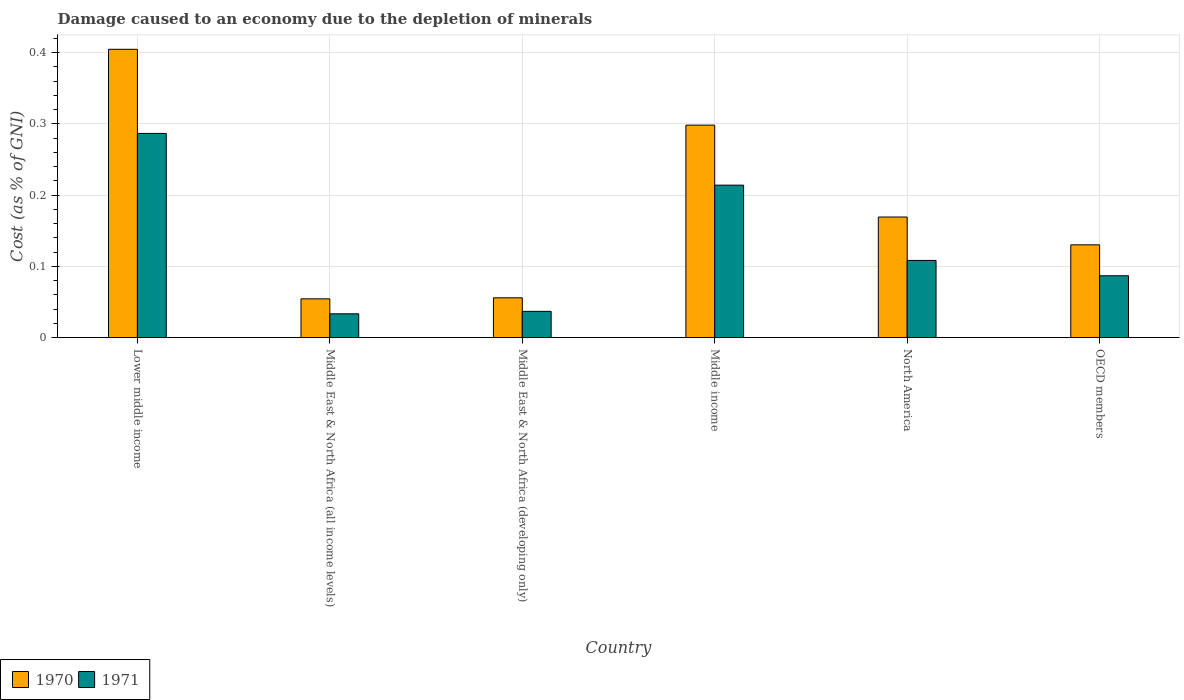How many different coloured bars are there?
Your answer should be very brief. 2. How many groups of bars are there?
Your answer should be very brief. 6. How many bars are there on the 5th tick from the left?
Provide a short and direct response. 2. How many bars are there on the 1st tick from the right?
Your response must be concise. 2. What is the cost of damage caused due to the depletion of minerals in 1970 in Lower middle income?
Ensure brevity in your answer.  0.4. Across all countries, what is the maximum cost of damage caused due to the depletion of minerals in 1970?
Your response must be concise. 0.4. Across all countries, what is the minimum cost of damage caused due to the depletion of minerals in 1970?
Your response must be concise. 0.05. In which country was the cost of damage caused due to the depletion of minerals in 1970 maximum?
Your answer should be compact. Lower middle income. In which country was the cost of damage caused due to the depletion of minerals in 1970 minimum?
Give a very brief answer. Middle East & North Africa (all income levels). What is the total cost of damage caused due to the depletion of minerals in 1970 in the graph?
Your response must be concise. 1.11. What is the difference between the cost of damage caused due to the depletion of minerals in 1971 in Middle East & North Africa (developing only) and that in OECD members?
Offer a terse response. -0.05. What is the difference between the cost of damage caused due to the depletion of minerals in 1971 in Lower middle income and the cost of damage caused due to the depletion of minerals in 1970 in Middle East & North Africa (all income levels)?
Keep it short and to the point. 0.23. What is the average cost of damage caused due to the depletion of minerals in 1971 per country?
Offer a very short reply. 0.13. What is the difference between the cost of damage caused due to the depletion of minerals of/in 1970 and cost of damage caused due to the depletion of minerals of/in 1971 in Middle East & North Africa (all income levels)?
Your answer should be very brief. 0.02. In how many countries, is the cost of damage caused due to the depletion of minerals in 1971 greater than 0.4 %?
Provide a short and direct response. 0. What is the ratio of the cost of damage caused due to the depletion of minerals in 1971 in Middle East & North Africa (all income levels) to that in Middle East & North Africa (developing only)?
Your answer should be very brief. 0.91. What is the difference between the highest and the second highest cost of damage caused due to the depletion of minerals in 1971?
Make the answer very short. 0.18. What is the difference between the highest and the lowest cost of damage caused due to the depletion of minerals in 1971?
Provide a short and direct response. 0.25. In how many countries, is the cost of damage caused due to the depletion of minerals in 1970 greater than the average cost of damage caused due to the depletion of minerals in 1970 taken over all countries?
Your response must be concise. 2. Is the sum of the cost of damage caused due to the depletion of minerals in 1970 in Middle income and OECD members greater than the maximum cost of damage caused due to the depletion of minerals in 1971 across all countries?
Keep it short and to the point. Yes. Are all the bars in the graph horizontal?
Your answer should be compact. No. Are the values on the major ticks of Y-axis written in scientific E-notation?
Your answer should be compact. No. Does the graph contain grids?
Your answer should be compact. Yes. How are the legend labels stacked?
Your answer should be very brief. Horizontal. What is the title of the graph?
Keep it short and to the point. Damage caused to an economy due to the depletion of minerals. What is the label or title of the X-axis?
Make the answer very short. Country. What is the label or title of the Y-axis?
Give a very brief answer. Cost (as % of GNI). What is the Cost (as % of GNI) in 1970 in Lower middle income?
Your answer should be compact. 0.4. What is the Cost (as % of GNI) in 1971 in Lower middle income?
Your answer should be compact. 0.29. What is the Cost (as % of GNI) in 1970 in Middle East & North Africa (all income levels)?
Your answer should be compact. 0.05. What is the Cost (as % of GNI) of 1971 in Middle East & North Africa (all income levels)?
Provide a succinct answer. 0.03. What is the Cost (as % of GNI) of 1970 in Middle East & North Africa (developing only)?
Provide a succinct answer. 0.06. What is the Cost (as % of GNI) of 1971 in Middle East & North Africa (developing only)?
Ensure brevity in your answer.  0.04. What is the Cost (as % of GNI) of 1970 in Middle income?
Your response must be concise. 0.3. What is the Cost (as % of GNI) in 1971 in Middle income?
Your response must be concise. 0.21. What is the Cost (as % of GNI) in 1970 in North America?
Ensure brevity in your answer.  0.17. What is the Cost (as % of GNI) in 1971 in North America?
Your response must be concise. 0.11. What is the Cost (as % of GNI) in 1970 in OECD members?
Keep it short and to the point. 0.13. What is the Cost (as % of GNI) of 1971 in OECD members?
Make the answer very short. 0.09. Across all countries, what is the maximum Cost (as % of GNI) of 1970?
Offer a very short reply. 0.4. Across all countries, what is the maximum Cost (as % of GNI) of 1971?
Provide a short and direct response. 0.29. Across all countries, what is the minimum Cost (as % of GNI) of 1970?
Keep it short and to the point. 0.05. Across all countries, what is the minimum Cost (as % of GNI) in 1971?
Keep it short and to the point. 0.03. What is the total Cost (as % of GNI) of 1970 in the graph?
Ensure brevity in your answer.  1.11. What is the total Cost (as % of GNI) of 1971 in the graph?
Ensure brevity in your answer.  0.77. What is the difference between the Cost (as % of GNI) in 1970 in Lower middle income and that in Middle East & North Africa (all income levels)?
Give a very brief answer. 0.35. What is the difference between the Cost (as % of GNI) in 1971 in Lower middle income and that in Middle East & North Africa (all income levels)?
Keep it short and to the point. 0.25. What is the difference between the Cost (as % of GNI) of 1970 in Lower middle income and that in Middle East & North Africa (developing only)?
Provide a short and direct response. 0.35. What is the difference between the Cost (as % of GNI) of 1971 in Lower middle income and that in Middle East & North Africa (developing only)?
Make the answer very short. 0.25. What is the difference between the Cost (as % of GNI) in 1970 in Lower middle income and that in Middle income?
Your answer should be very brief. 0.11. What is the difference between the Cost (as % of GNI) in 1971 in Lower middle income and that in Middle income?
Your answer should be compact. 0.07. What is the difference between the Cost (as % of GNI) in 1970 in Lower middle income and that in North America?
Your answer should be very brief. 0.24. What is the difference between the Cost (as % of GNI) in 1971 in Lower middle income and that in North America?
Offer a terse response. 0.18. What is the difference between the Cost (as % of GNI) in 1970 in Lower middle income and that in OECD members?
Provide a short and direct response. 0.27. What is the difference between the Cost (as % of GNI) in 1971 in Lower middle income and that in OECD members?
Make the answer very short. 0.2. What is the difference between the Cost (as % of GNI) of 1970 in Middle East & North Africa (all income levels) and that in Middle East & North Africa (developing only)?
Your answer should be very brief. -0. What is the difference between the Cost (as % of GNI) in 1971 in Middle East & North Africa (all income levels) and that in Middle East & North Africa (developing only)?
Your answer should be very brief. -0. What is the difference between the Cost (as % of GNI) of 1970 in Middle East & North Africa (all income levels) and that in Middle income?
Ensure brevity in your answer.  -0.24. What is the difference between the Cost (as % of GNI) in 1971 in Middle East & North Africa (all income levels) and that in Middle income?
Provide a short and direct response. -0.18. What is the difference between the Cost (as % of GNI) of 1970 in Middle East & North Africa (all income levels) and that in North America?
Offer a very short reply. -0.11. What is the difference between the Cost (as % of GNI) of 1971 in Middle East & North Africa (all income levels) and that in North America?
Provide a succinct answer. -0.07. What is the difference between the Cost (as % of GNI) in 1970 in Middle East & North Africa (all income levels) and that in OECD members?
Keep it short and to the point. -0.08. What is the difference between the Cost (as % of GNI) of 1971 in Middle East & North Africa (all income levels) and that in OECD members?
Provide a short and direct response. -0.05. What is the difference between the Cost (as % of GNI) in 1970 in Middle East & North Africa (developing only) and that in Middle income?
Provide a short and direct response. -0.24. What is the difference between the Cost (as % of GNI) in 1971 in Middle East & North Africa (developing only) and that in Middle income?
Your response must be concise. -0.18. What is the difference between the Cost (as % of GNI) of 1970 in Middle East & North Africa (developing only) and that in North America?
Make the answer very short. -0.11. What is the difference between the Cost (as % of GNI) of 1971 in Middle East & North Africa (developing only) and that in North America?
Provide a succinct answer. -0.07. What is the difference between the Cost (as % of GNI) of 1970 in Middle East & North Africa (developing only) and that in OECD members?
Ensure brevity in your answer.  -0.07. What is the difference between the Cost (as % of GNI) in 1971 in Middle East & North Africa (developing only) and that in OECD members?
Offer a very short reply. -0.05. What is the difference between the Cost (as % of GNI) of 1970 in Middle income and that in North America?
Provide a succinct answer. 0.13. What is the difference between the Cost (as % of GNI) of 1971 in Middle income and that in North America?
Ensure brevity in your answer.  0.11. What is the difference between the Cost (as % of GNI) of 1970 in Middle income and that in OECD members?
Your response must be concise. 0.17. What is the difference between the Cost (as % of GNI) of 1971 in Middle income and that in OECD members?
Offer a terse response. 0.13. What is the difference between the Cost (as % of GNI) of 1970 in North America and that in OECD members?
Your response must be concise. 0.04. What is the difference between the Cost (as % of GNI) in 1971 in North America and that in OECD members?
Provide a succinct answer. 0.02. What is the difference between the Cost (as % of GNI) in 1970 in Lower middle income and the Cost (as % of GNI) in 1971 in Middle East & North Africa (all income levels)?
Your answer should be compact. 0.37. What is the difference between the Cost (as % of GNI) in 1970 in Lower middle income and the Cost (as % of GNI) in 1971 in Middle East & North Africa (developing only)?
Offer a terse response. 0.37. What is the difference between the Cost (as % of GNI) in 1970 in Lower middle income and the Cost (as % of GNI) in 1971 in Middle income?
Your answer should be compact. 0.19. What is the difference between the Cost (as % of GNI) of 1970 in Lower middle income and the Cost (as % of GNI) of 1971 in North America?
Your answer should be very brief. 0.3. What is the difference between the Cost (as % of GNI) of 1970 in Lower middle income and the Cost (as % of GNI) of 1971 in OECD members?
Your answer should be very brief. 0.32. What is the difference between the Cost (as % of GNI) in 1970 in Middle East & North Africa (all income levels) and the Cost (as % of GNI) in 1971 in Middle East & North Africa (developing only)?
Make the answer very short. 0.02. What is the difference between the Cost (as % of GNI) of 1970 in Middle East & North Africa (all income levels) and the Cost (as % of GNI) of 1971 in Middle income?
Make the answer very short. -0.16. What is the difference between the Cost (as % of GNI) of 1970 in Middle East & North Africa (all income levels) and the Cost (as % of GNI) of 1971 in North America?
Make the answer very short. -0.05. What is the difference between the Cost (as % of GNI) in 1970 in Middle East & North Africa (all income levels) and the Cost (as % of GNI) in 1971 in OECD members?
Your answer should be very brief. -0.03. What is the difference between the Cost (as % of GNI) in 1970 in Middle East & North Africa (developing only) and the Cost (as % of GNI) in 1971 in Middle income?
Your response must be concise. -0.16. What is the difference between the Cost (as % of GNI) of 1970 in Middle East & North Africa (developing only) and the Cost (as % of GNI) of 1971 in North America?
Ensure brevity in your answer.  -0.05. What is the difference between the Cost (as % of GNI) in 1970 in Middle East & North Africa (developing only) and the Cost (as % of GNI) in 1971 in OECD members?
Provide a short and direct response. -0.03. What is the difference between the Cost (as % of GNI) in 1970 in Middle income and the Cost (as % of GNI) in 1971 in North America?
Your response must be concise. 0.19. What is the difference between the Cost (as % of GNI) in 1970 in Middle income and the Cost (as % of GNI) in 1971 in OECD members?
Offer a very short reply. 0.21. What is the difference between the Cost (as % of GNI) of 1970 in North America and the Cost (as % of GNI) of 1971 in OECD members?
Make the answer very short. 0.08. What is the average Cost (as % of GNI) in 1970 per country?
Your answer should be very brief. 0.19. What is the average Cost (as % of GNI) in 1971 per country?
Ensure brevity in your answer.  0.13. What is the difference between the Cost (as % of GNI) in 1970 and Cost (as % of GNI) in 1971 in Lower middle income?
Give a very brief answer. 0.12. What is the difference between the Cost (as % of GNI) in 1970 and Cost (as % of GNI) in 1971 in Middle East & North Africa (all income levels)?
Ensure brevity in your answer.  0.02. What is the difference between the Cost (as % of GNI) of 1970 and Cost (as % of GNI) of 1971 in Middle East & North Africa (developing only)?
Keep it short and to the point. 0.02. What is the difference between the Cost (as % of GNI) of 1970 and Cost (as % of GNI) of 1971 in Middle income?
Your answer should be very brief. 0.08. What is the difference between the Cost (as % of GNI) of 1970 and Cost (as % of GNI) of 1971 in North America?
Your response must be concise. 0.06. What is the difference between the Cost (as % of GNI) of 1970 and Cost (as % of GNI) of 1971 in OECD members?
Give a very brief answer. 0.04. What is the ratio of the Cost (as % of GNI) of 1970 in Lower middle income to that in Middle East & North Africa (all income levels)?
Give a very brief answer. 7.43. What is the ratio of the Cost (as % of GNI) in 1971 in Lower middle income to that in Middle East & North Africa (all income levels)?
Keep it short and to the point. 8.56. What is the ratio of the Cost (as % of GNI) in 1970 in Lower middle income to that in Middle East & North Africa (developing only)?
Make the answer very short. 7.24. What is the ratio of the Cost (as % of GNI) in 1971 in Lower middle income to that in Middle East & North Africa (developing only)?
Ensure brevity in your answer.  7.76. What is the ratio of the Cost (as % of GNI) in 1970 in Lower middle income to that in Middle income?
Ensure brevity in your answer.  1.36. What is the ratio of the Cost (as % of GNI) of 1971 in Lower middle income to that in Middle income?
Ensure brevity in your answer.  1.34. What is the ratio of the Cost (as % of GNI) of 1970 in Lower middle income to that in North America?
Provide a succinct answer. 2.39. What is the ratio of the Cost (as % of GNI) in 1971 in Lower middle income to that in North America?
Your answer should be compact. 2.64. What is the ratio of the Cost (as % of GNI) of 1970 in Lower middle income to that in OECD members?
Provide a succinct answer. 3.11. What is the ratio of the Cost (as % of GNI) in 1971 in Lower middle income to that in OECD members?
Your answer should be very brief. 3.3. What is the ratio of the Cost (as % of GNI) in 1970 in Middle East & North Africa (all income levels) to that in Middle East & North Africa (developing only)?
Ensure brevity in your answer.  0.97. What is the ratio of the Cost (as % of GNI) of 1971 in Middle East & North Africa (all income levels) to that in Middle East & North Africa (developing only)?
Offer a terse response. 0.91. What is the ratio of the Cost (as % of GNI) of 1970 in Middle East & North Africa (all income levels) to that in Middle income?
Keep it short and to the point. 0.18. What is the ratio of the Cost (as % of GNI) in 1971 in Middle East & North Africa (all income levels) to that in Middle income?
Your response must be concise. 0.16. What is the ratio of the Cost (as % of GNI) in 1970 in Middle East & North Africa (all income levels) to that in North America?
Your answer should be compact. 0.32. What is the ratio of the Cost (as % of GNI) in 1971 in Middle East & North Africa (all income levels) to that in North America?
Your response must be concise. 0.31. What is the ratio of the Cost (as % of GNI) of 1970 in Middle East & North Africa (all income levels) to that in OECD members?
Keep it short and to the point. 0.42. What is the ratio of the Cost (as % of GNI) in 1971 in Middle East & North Africa (all income levels) to that in OECD members?
Make the answer very short. 0.39. What is the ratio of the Cost (as % of GNI) in 1970 in Middle East & North Africa (developing only) to that in Middle income?
Offer a very short reply. 0.19. What is the ratio of the Cost (as % of GNI) of 1971 in Middle East & North Africa (developing only) to that in Middle income?
Give a very brief answer. 0.17. What is the ratio of the Cost (as % of GNI) in 1970 in Middle East & North Africa (developing only) to that in North America?
Your answer should be very brief. 0.33. What is the ratio of the Cost (as % of GNI) in 1971 in Middle East & North Africa (developing only) to that in North America?
Ensure brevity in your answer.  0.34. What is the ratio of the Cost (as % of GNI) in 1970 in Middle East & North Africa (developing only) to that in OECD members?
Provide a succinct answer. 0.43. What is the ratio of the Cost (as % of GNI) in 1971 in Middle East & North Africa (developing only) to that in OECD members?
Give a very brief answer. 0.43. What is the ratio of the Cost (as % of GNI) of 1970 in Middle income to that in North America?
Your answer should be very brief. 1.76. What is the ratio of the Cost (as % of GNI) in 1971 in Middle income to that in North America?
Your answer should be very brief. 1.97. What is the ratio of the Cost (as % of GNI) in 1970 in Middle income to that in OECD members?
Keep it short and to the point. 2.29. What is the ratio of the Cost (as % of GNI) of 1971 in Middle income to that in OECD members?
Keep it short and to the point. 2.46. What is the ratio of the Cost (as % of GNI) of 1970 in North America to that in OECD members?
Keep it short and to the point. 1.3. What is the ratio of the Cost (as % of GNI) of 1971 in North America to that in OECD members?
Your answer should be very brief. 1.25. What is the difference between the highest and the second highest Cost (as % of GNI) of 1970?
Your answer should be compact. 0.11. What is the difference between the highest and the second highest Cost (as % of GNI) of 1971?
Provide a short and direct response. 0.07. What is the difference between the highest and the lowest Cost (as % of GNI) of 1970?
Your answer should be compact. 0.35. What is the difference between the highest and the lowest Cost (as % of GNI) of 1971?
Offer a terse response. 0.25. 